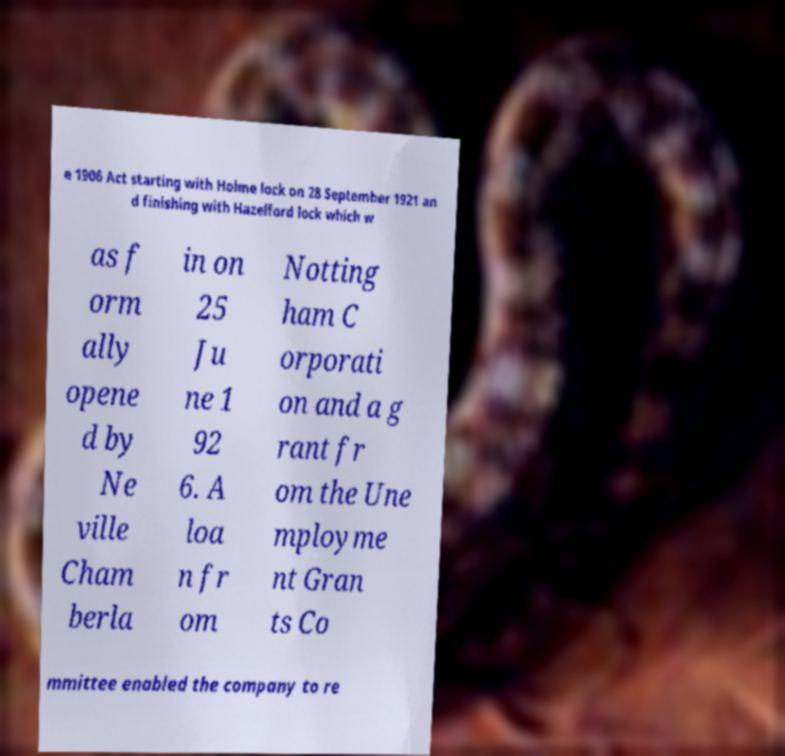What messages or text are displayed in this image? I need them in a readable, typed format. e 1906 Act starting with Holme lock on 28 September 1921 an d finishing with Hazelford lock which w as f orm ally opene d by Ne ville Cham berla in on 25 Ju ne 1 92 6. A loa n fr om Notting ham C orporati on and a g rant fr om the Une mployme nt Gran ts Co mmittee enabled the company to re 